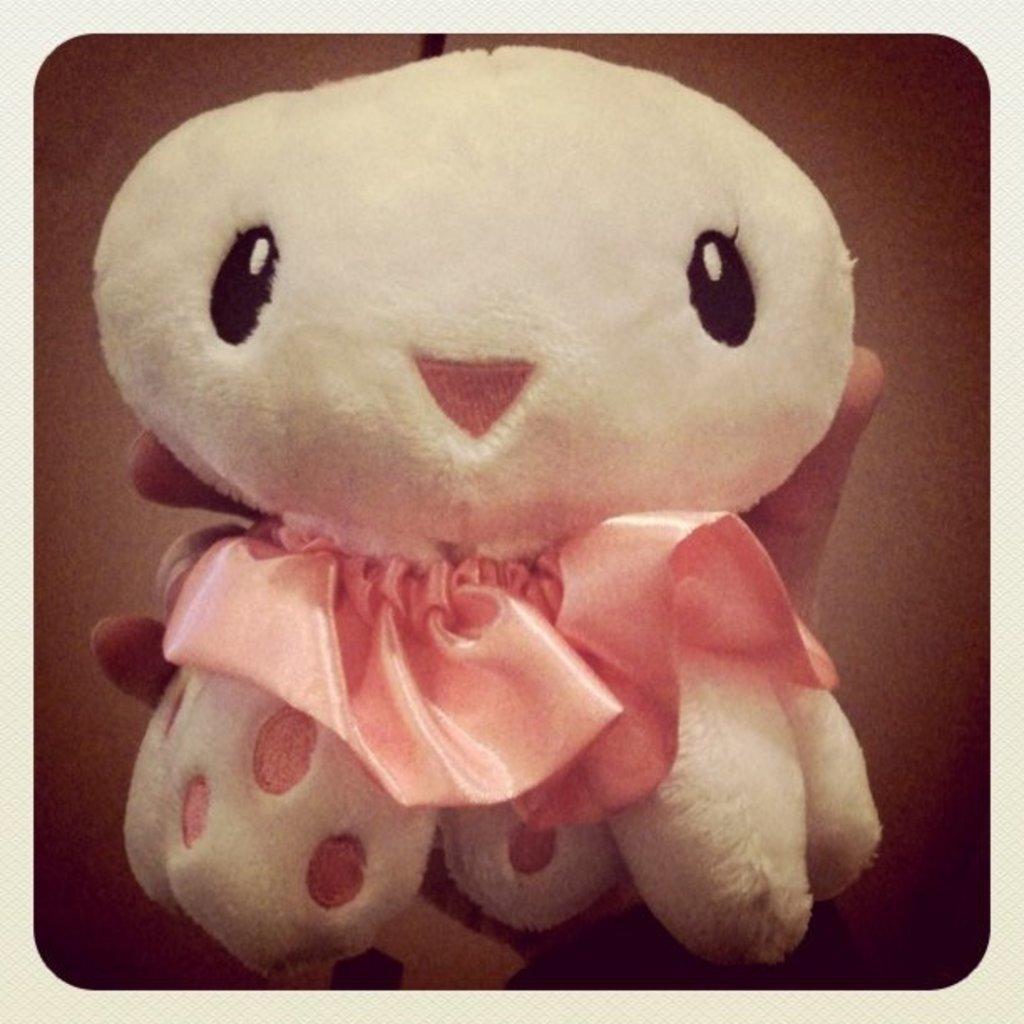How would you summarize this image in a sentence or two? In this image there is personś hand holding the object. 